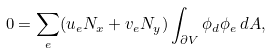Convert formula to latex. <formula><loc_0><loc_0><loc_500><loc_500>0 = \sum _ { e } ( u _ { e } N _ { x } + v _ { e } N _ { y } ) \int _ { \partial V } \phi _ { d } \phi _ { e } \, d A ,</formula> 